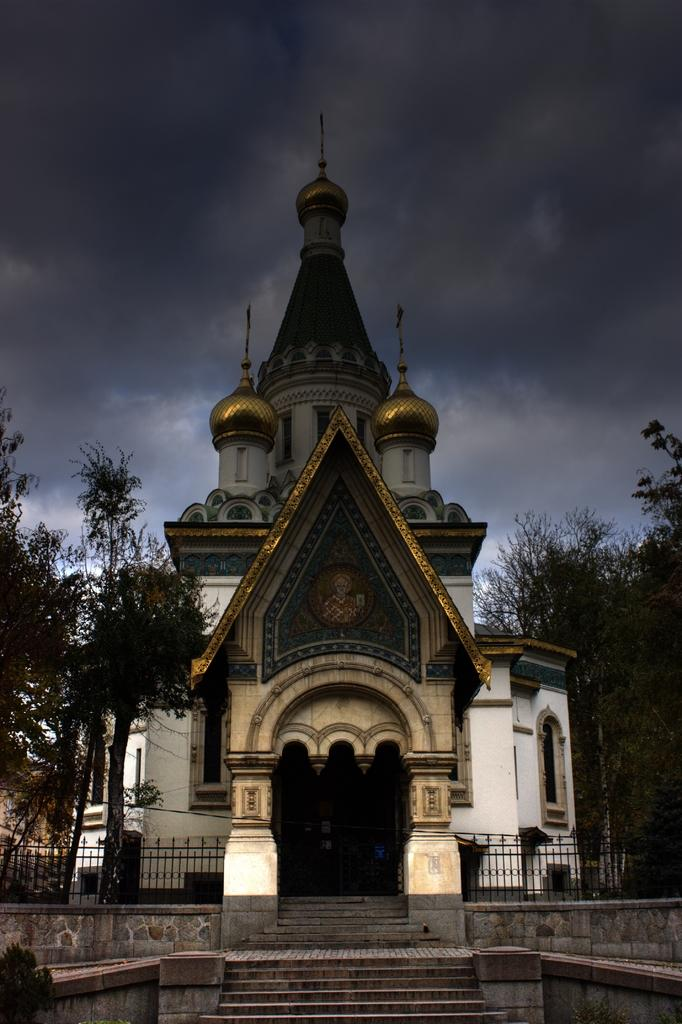What is the weather like in the image? The sky is cloudy in the image. What type of structure is visible in the image? There is a building with windows in the image. What can be seen beside the building? There are trees beside the building. What is in front of the building? There is a fence and steps in front of the building. What type of acoustics can be heard coming from the building in the image? There is no information about the acoustics or any sounds coming from the building in the image. 